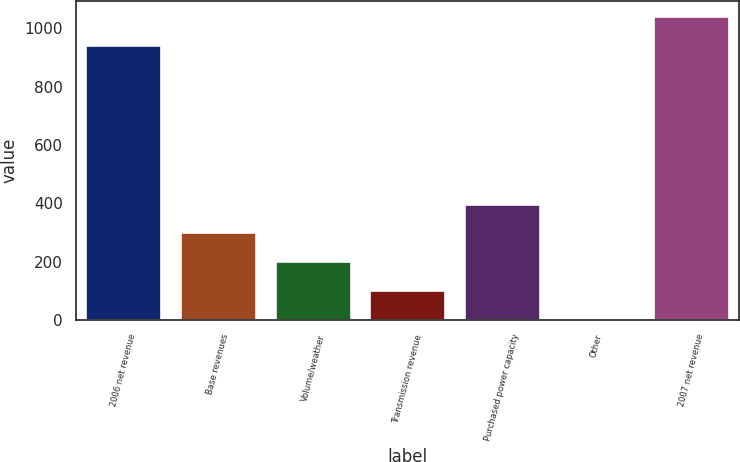<chart> <loc_0><loc_0><loc_500><loc_500><bar_chart><fcel>2006 net revenue<fcel>Base revenues<fcel>Volume/weather<fcel>Transmission revenue<fcel>Purchased power capacity<fcel>Other<fcel>2007 net revenue<nl><fcel>942.1<fcel>300.06<fcel>201.34<fcel>102.62<fcel>398.78<fcel>3.9<fcel>1040.82<nl></chart> 